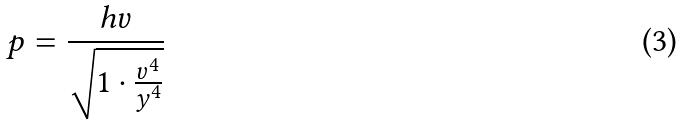Convert formula to latex. <formula><loc_0><loc_0><loc_500><loc_500>p = \frac { h v } { \sqrt { 1 \cdot \frac { v ^ { 4 } } { y ^ { 4 } } } }</formula> 